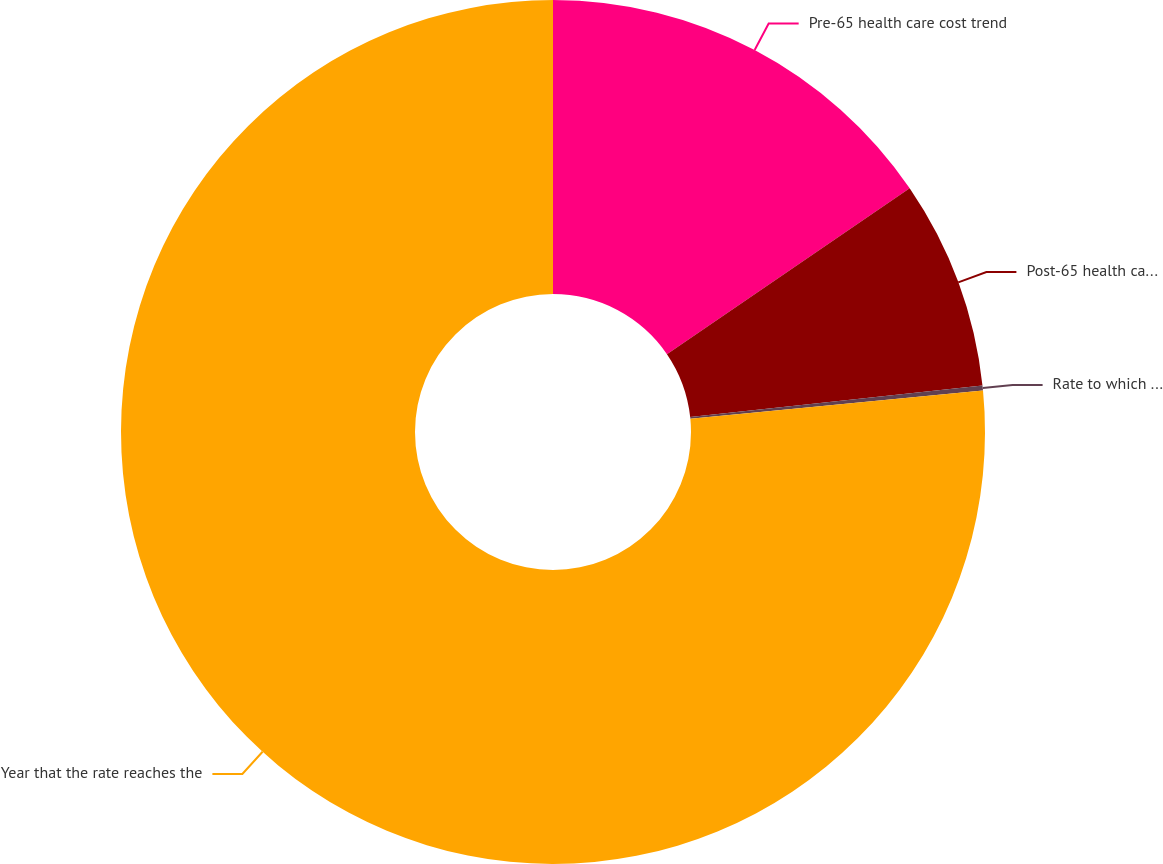Convert chart. <chart><loc_0><loc_0><loc_500><loc_500><pie_chart><fcel>Pre-65 health care cost trend<fcel>Post-65 health care cost trend<fcel>Rate to which the cost trend<fcel>Year that the rate reaches the<nl><fcel>15.46%<fcel>7.82%<fcel>0.19%<fcel>76.53%<nl></chart> 